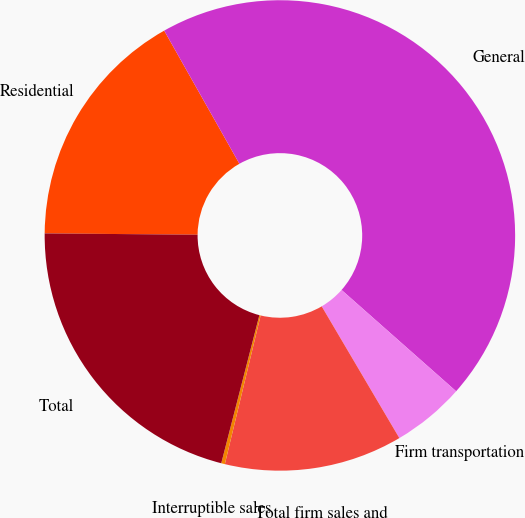Convert chart to OTSL. <chart><loc_0><loc_0><loc_500><loc_500><pie_chart><fcel>Residential<fcel>General<fcel>Firm transportation<fcel>Total firm sales and<fcel>Interruptible sales<fcel>Total<nl><fcel>16.68%<fcel>44.71%<fcel>5.0%<fcel>12.24%<fcel>0.25%<fcel>21.13%<nl></chart> 